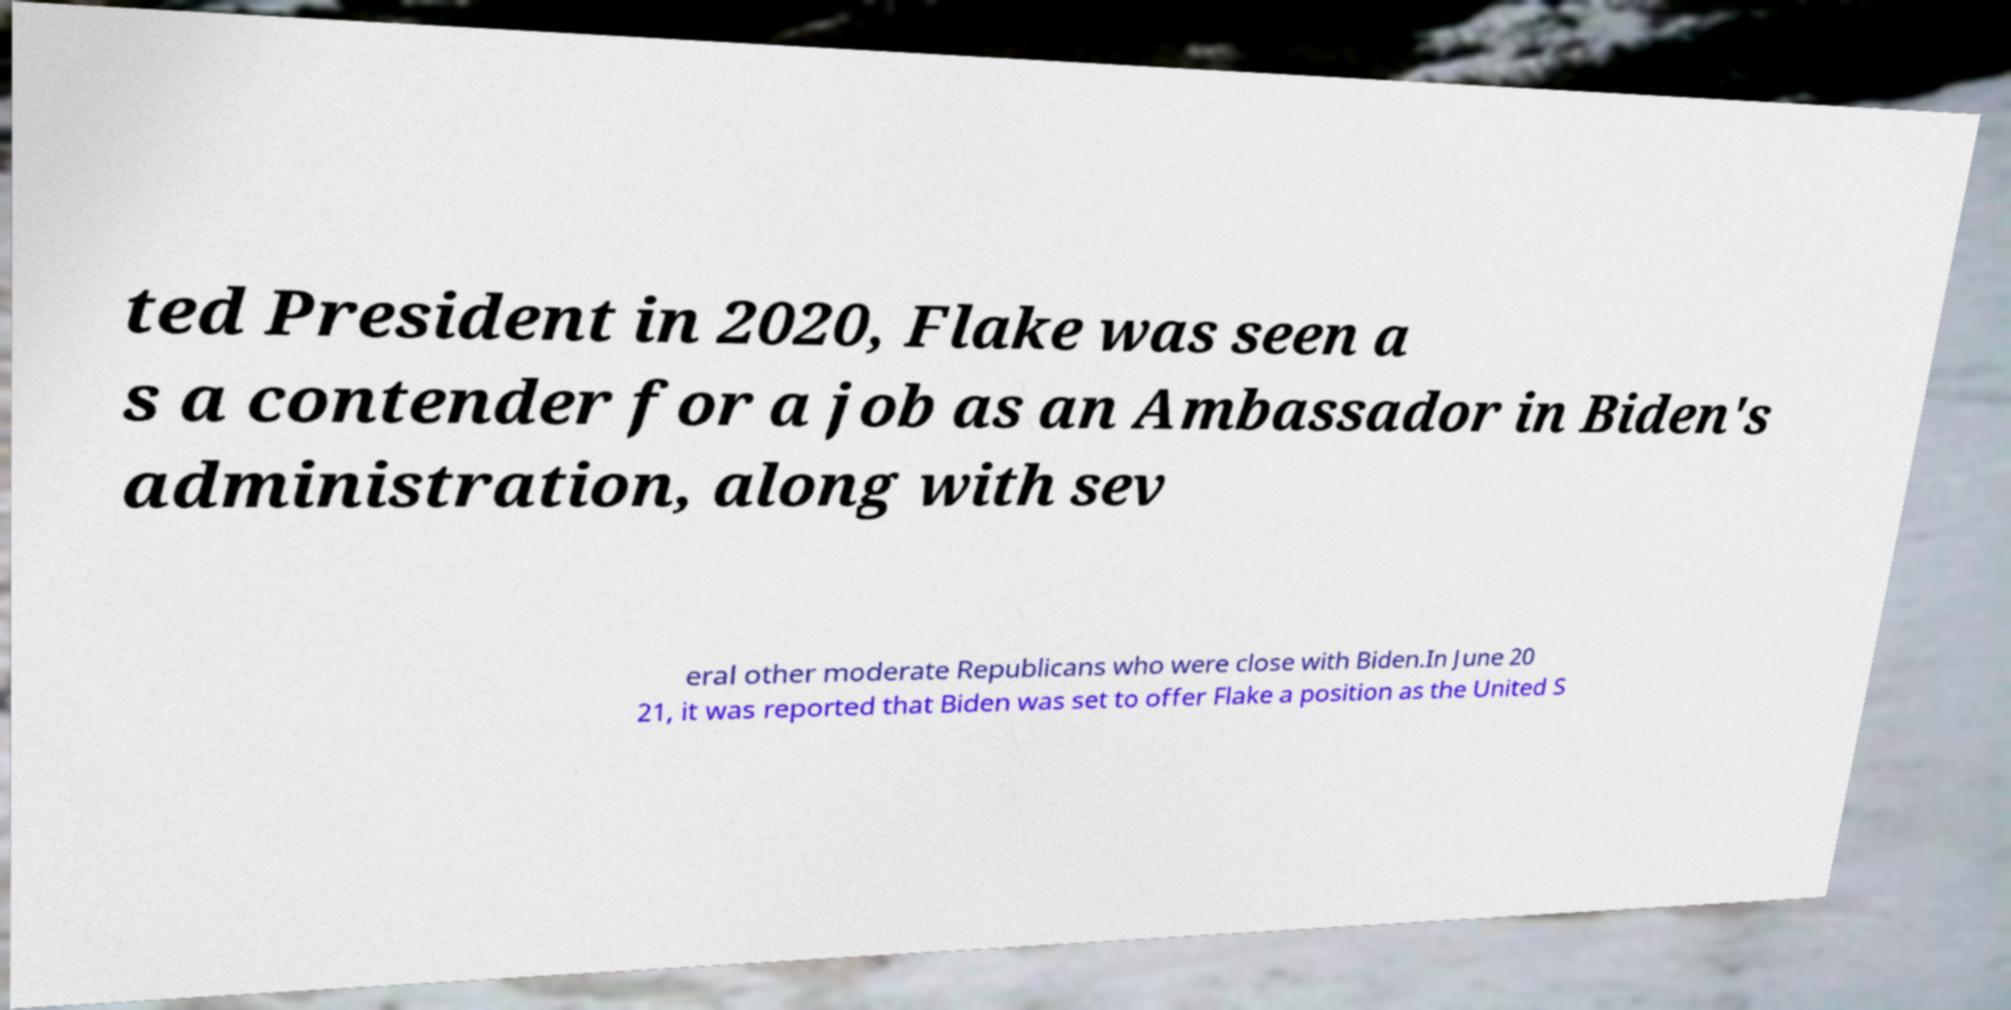There's text embedded in this image that I need extracted. Can you transcribe it verbatim? ted President in 2020, Flake was seen a s a contender for a job as an Ambassador in Biden's administration, along with sev eral other moderate Republicans who were close with Biden.In June 20 21, it was reported that Biden was set to offer Flake a position as the United S 